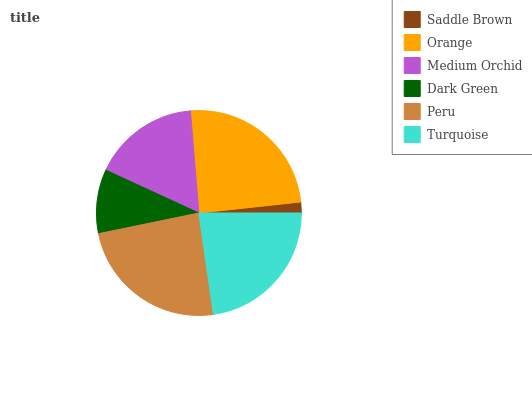Is Saddle Brown the minimum?
Answer yes or no. Yes. Is Orange the maximum?
Answer yes or no. Yes. Is Medium Orchid the minimum?
Answer yes or no. No. Is Medium Orchid the maximum?
Answer yes or no. No. Is Orange greater than Medium Orchid?
Answer yes or no. Yes. Is Medium Orchid less than Orange?
Answer yes or no. Yes. Is Medium Orchid greater than Orange?
Answer yes or no. No. Is Orange less than Medium Orchid?
Answer yes or no. No. Is Turquoise the high median?
Answer yes or no. Yes. Is Medium Orchid the low median?
Answer yes or no. Yes. Is Dark Green the high median?
Answer yes or no. No. Is Orange the low median?
Answer yes or no. No. 